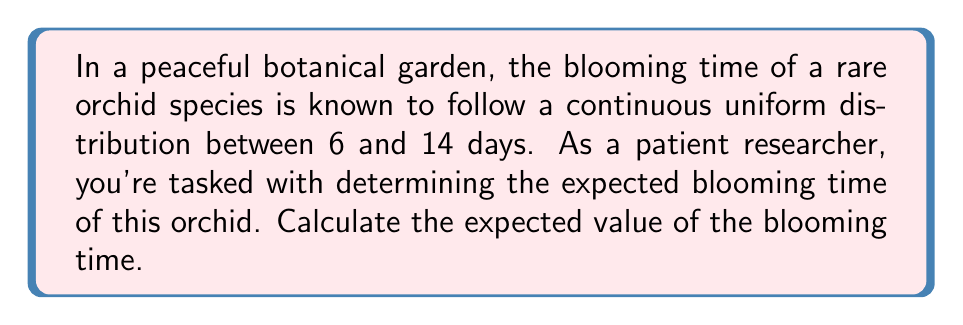Could you help me with this problem? Let's approach this problem step-by-step in a calm and focused manner:

1) First, we identify that we're dealing with a continuous uniform distribution. The probability density function (PDF) for a uniform distribution between $a$ and $b$ is given by:

   $$f(x) = \begin{cases} 
   \frac{1}{b-a} & \text{for } a \leq x \leq b \\
   0 & \text{otherwise}
   \end{cases}$$

2) In this case, $a = 6$ and $b = 14$.

3) The expected value of a continuous random variable $X$ is given by the formula:

   $$E[X] = \int_{-\infty}^{\infty} x f(x) dx$$

4) For our uniform distribution, this becomes:

   $$E[X] = \int_{6}^{14} x \cdot \frac{1}{14-6} dx = \frac{1}{8} \int_{6}^{14} x dx$$

5) Let's solve this integral:

   $$E[X] = \frac{1}{8} \left[ \frac{x^2}{2} \right]_{6}^{14}$$

6) Evaluating the integral:

   $$E[X] = \frac{1}{8} \left( \frac{14^2}{2} - \frac{6^2}{2} \right)$$

7) Simplifying:

   $$E[X] = \frac{1}{8} \left( \frac{196 - 36}{2} \right) = \frac{160}{16} = 10$$

Therefore, the expected blooming time of the orchid is 10 days.
Answer: $E[X] = 10$ days 